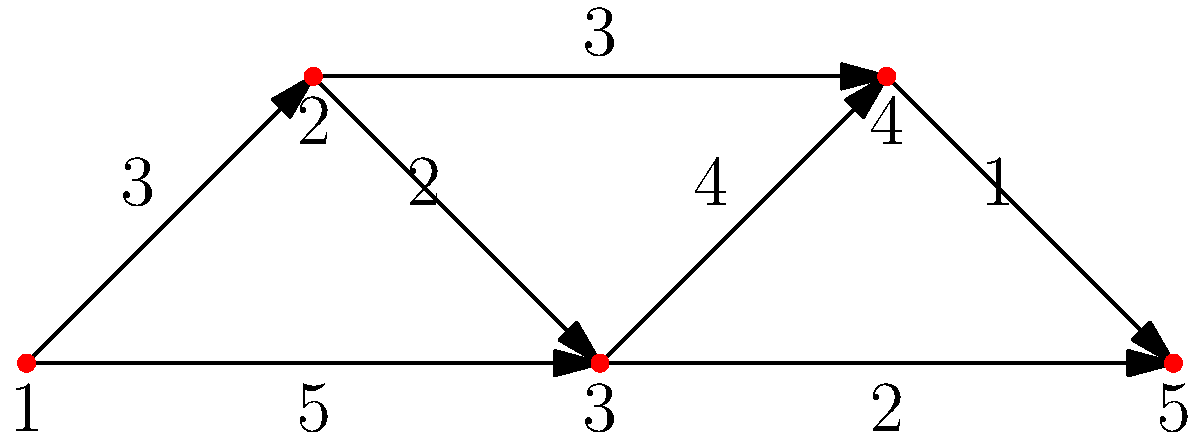Consider the network graph representing trade routes between five medieval Eurasian cities. The nodes represent cities, and the edges represent trade routes with associated travel times (in days). Using Dijkstra's algorithm, what is the shortest path from City 1 to City 5, and what is the total travel time along this path? To solve this problem, we'll apply Dijkstra's algorithm to find the shortest path from City 1 to City 5:

1. Initialize:
   - Set distance to City 1 as 0, all others as infinity.
   - Set all cities as unvisited.

2. For the current city (starting with City 1), consider all unvisited neighbors and calculate their tentative distances:
   - City 1 to City 2: 3 days
   - City 1 to City 3: 5 days

3. Mark City 1 as visited. City 2 has the smallest tentative distance (3 days), so we move to City 2.

4. Update distances from City 2:
   - City 2 to City 3: 3 + 2 = 5 days (no change)
   - City 2 to City 4: 3 + 3 = 6 days

5. Mark City 2 as visited. City 3 has the smallest tentative distance (5 days), so we move to City 3.

6. Update distances from City 3:
   - City 3 to City 4: 5 + 4 = 9 days (no improvement)
   - City 3 to City 5: 5 + 2 = 7 days

7. Mark City 3 as visited. City 4 has the smallest tentative distance (6 days), so we move to City 4.

8. Update distances from City 4:
   - City 4 to City 5: 6 + 1 = 7 days

9. Mark City 4 as visited. City 5 is the only unvisited city left, so we're done.

The shortest path from City 1 to City 5 is: City 1 → City 2 → City 4 → City 5
The total travel time along this path is 3 + 3 + 1 = 7 days.
Answer: Path: 1 → 2 → 4 → 5; Time: 7 days 